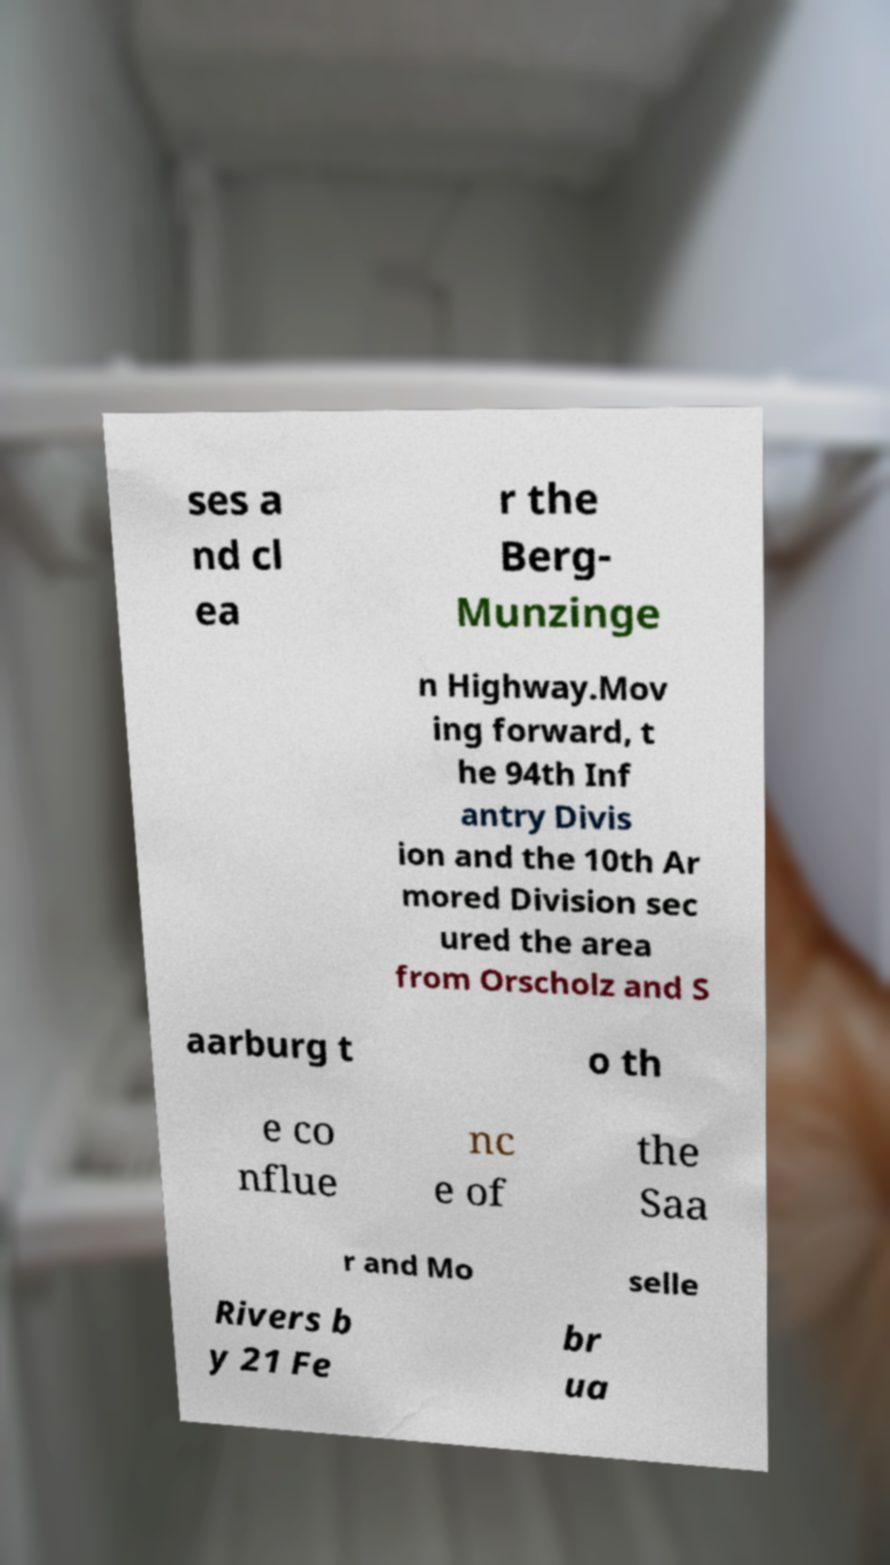Can you read and provide the text displayed in the image?This photo seems to have some interesting text. Can you extract and type it out for me? ses a nd cl ea r the Berg- Munzinge n Highway.Mov ing forward, t he 94th Inf antry Divis ion and the 10th Ar mored Division sec ured the area from Orscholz and S aarburg t o th e co nflue nc e of the Saa r and Mo selle Rivers b y 21 Fe br ua 